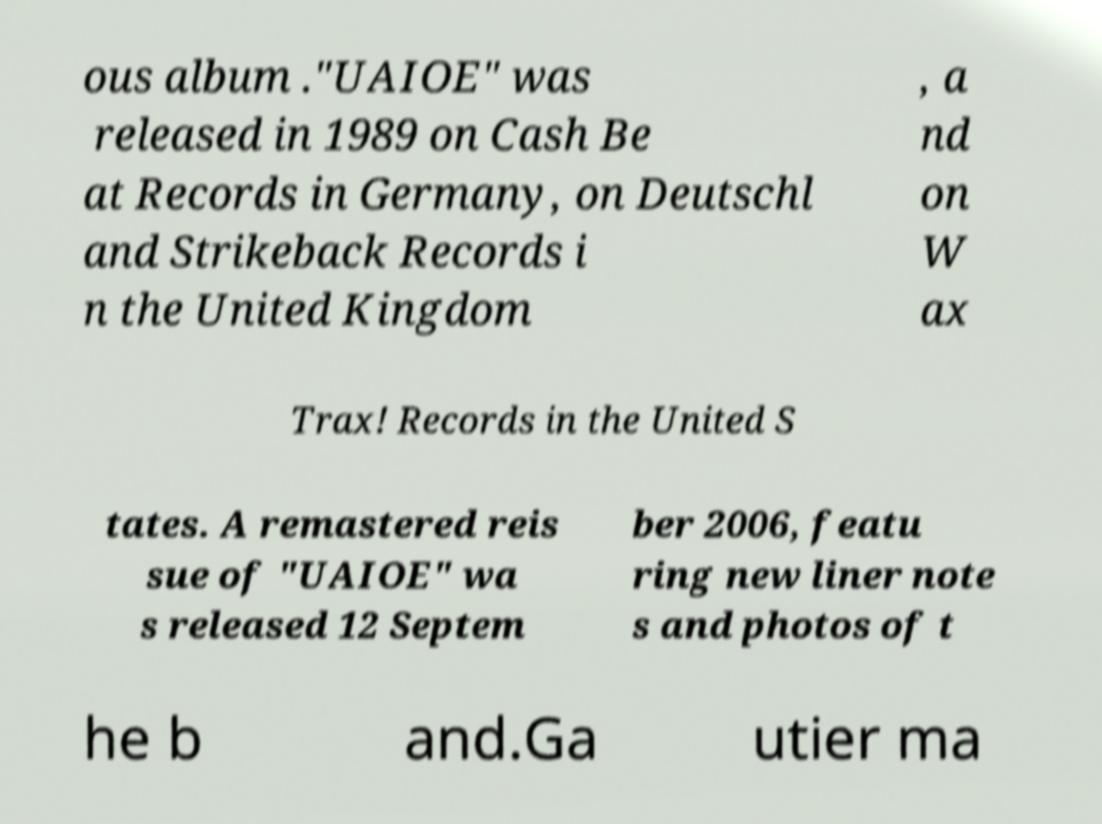Could you extract and type out the text from this image? ous album ."UAIOE" was released in 1989 on Cash Be at Records in Germany, on Deutschl and Strikeback Records i n the United Kingdom , a nd on W ax Trax! Records in the United S tates. A remastered reis sue of "UAIOE" wa s released 12 Septem ber 2006, featu ring new liner note s and photos of t he b and.Ga utier ma 